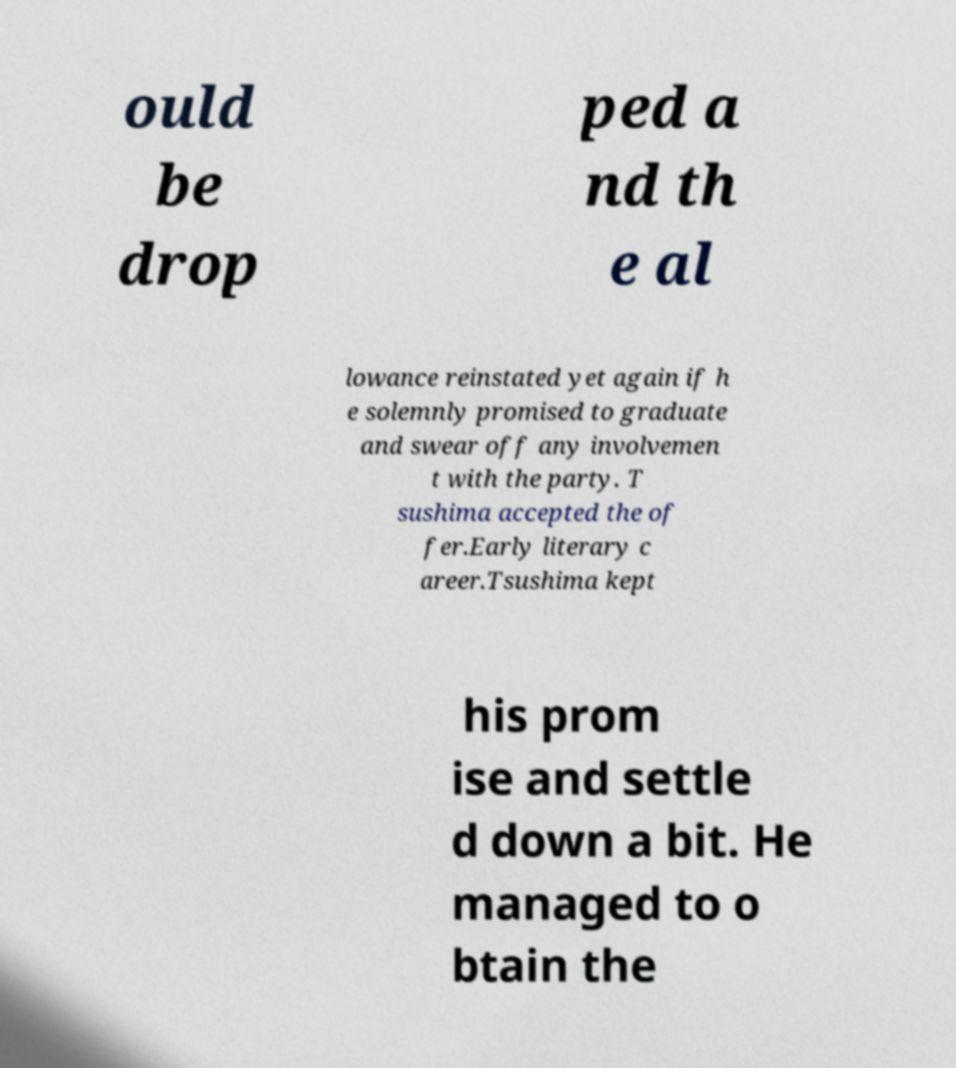Please identify and transcribe the text found in this image. ould be drop ped a nd th e al lowance reinstated yet again if h e solemnly promised to graduate and swear off any involvemen t with the party. T sushima accepted the of fer.Early literary c areer.Tsushima kept his prom ise and settle d down a bit. He managed to o btain the 